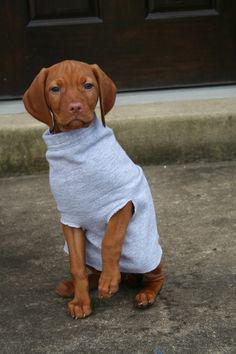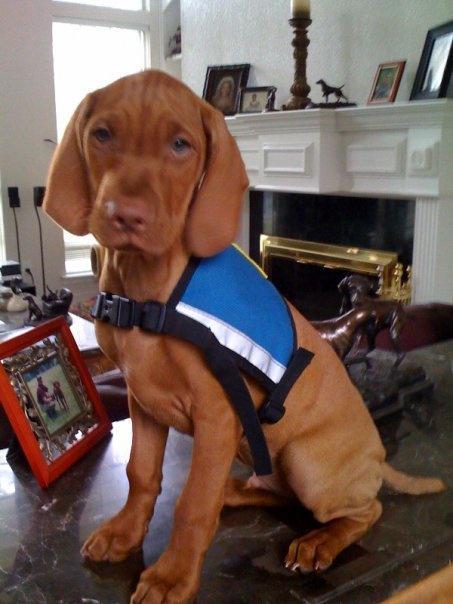The first image is the image on the left, the second image is the image on the right. Examine the images to the left and right. Is the description "One dog is wearing a sweater." accurate? Answer yes or no. Yes. The first image is the image on the left, the second image is the image on the right. Given the left and right images, does the statement "One image shows a dog wearing a harness and the other shows a dog wearing a shirt." hold true? Answer yes or no. Yes. 